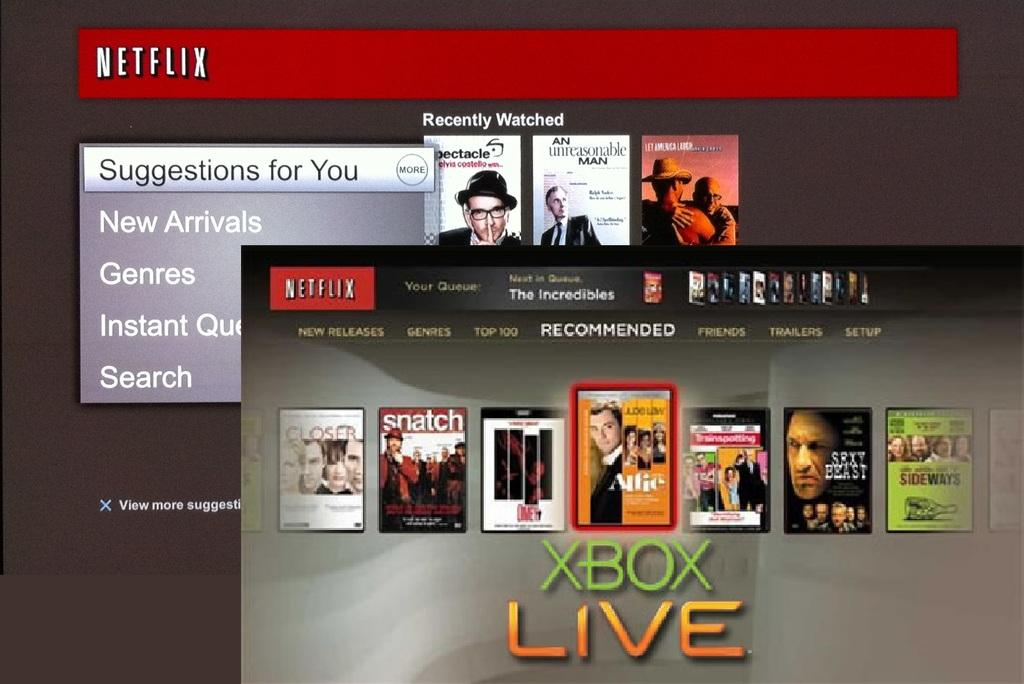Provide a one-sentence caption for the provided image. an xbox live screen with movies on it. 